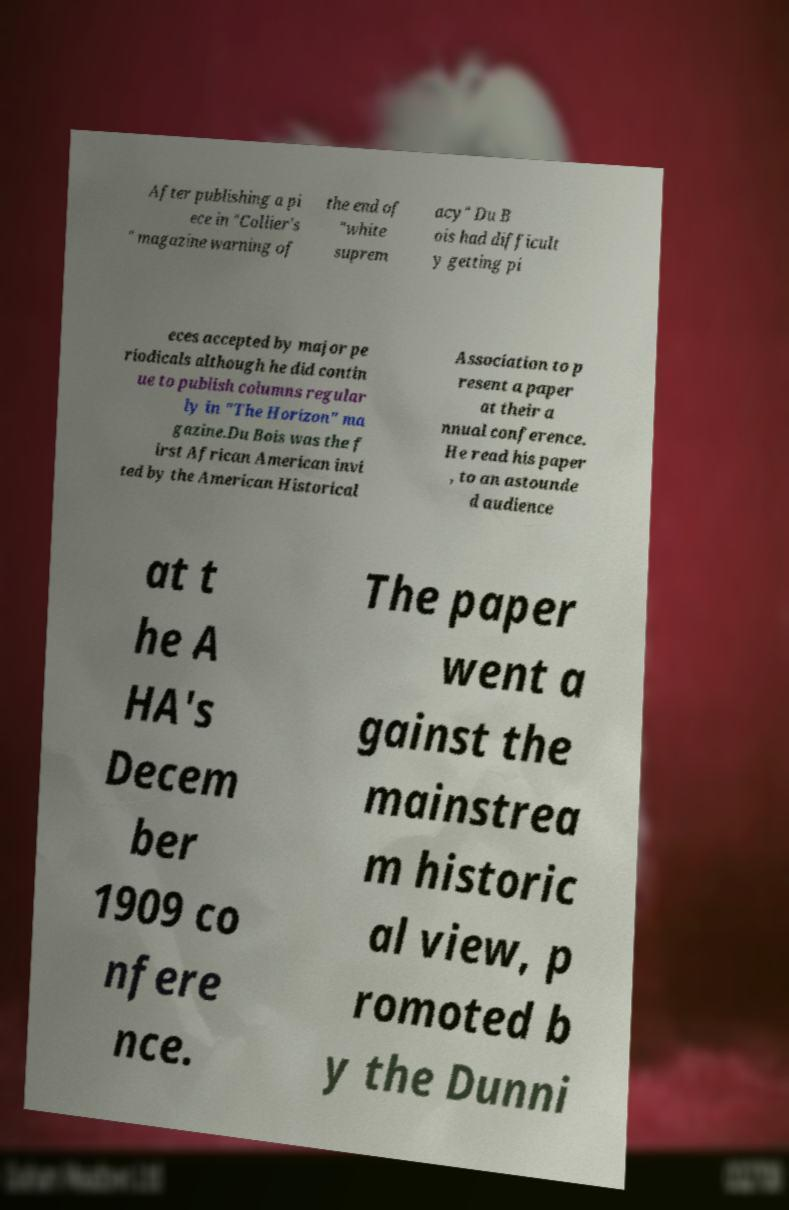For documentation purposes, I need the text within this image transcribed. Could you provide that? After publishing a pi ece in "Collier's " magazine warning of the end of "white suprem acy" Du B ois had difficult y getting pi eces accepted by major pe riodicals although he did contin ue to publish columns regular ly in "The Horizon" ma gazine.Du Bois was the f irst African American invi ted by the American Historical Association to p resent a paper at their a nnual conference. He read his paper , to an astounde d audience at t he A HA's Decem ber 1909 co nfere nce. The paper went a gainst the mainstrea m historic al view, p romoted b y the Dunni 